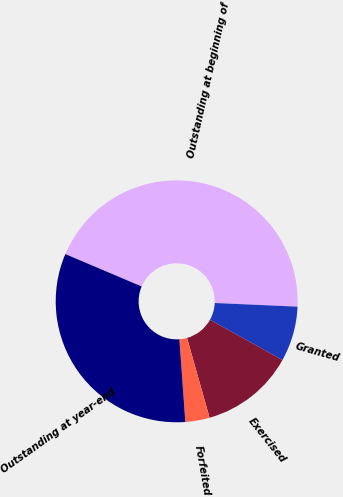<chart> <loc_0><loc_0><loc_500><loc_500><pie_chart><fcel>Outstanding at beginning of<fcel>Granted<fcel>Exercised<fcel>Forfeited<fcel>Outstanding at year-end<nl><fcel>44.32%<fcel>7.36%<fcel>12.55%<fcel>3.25%<fcel>32.52%<nl></chart> 